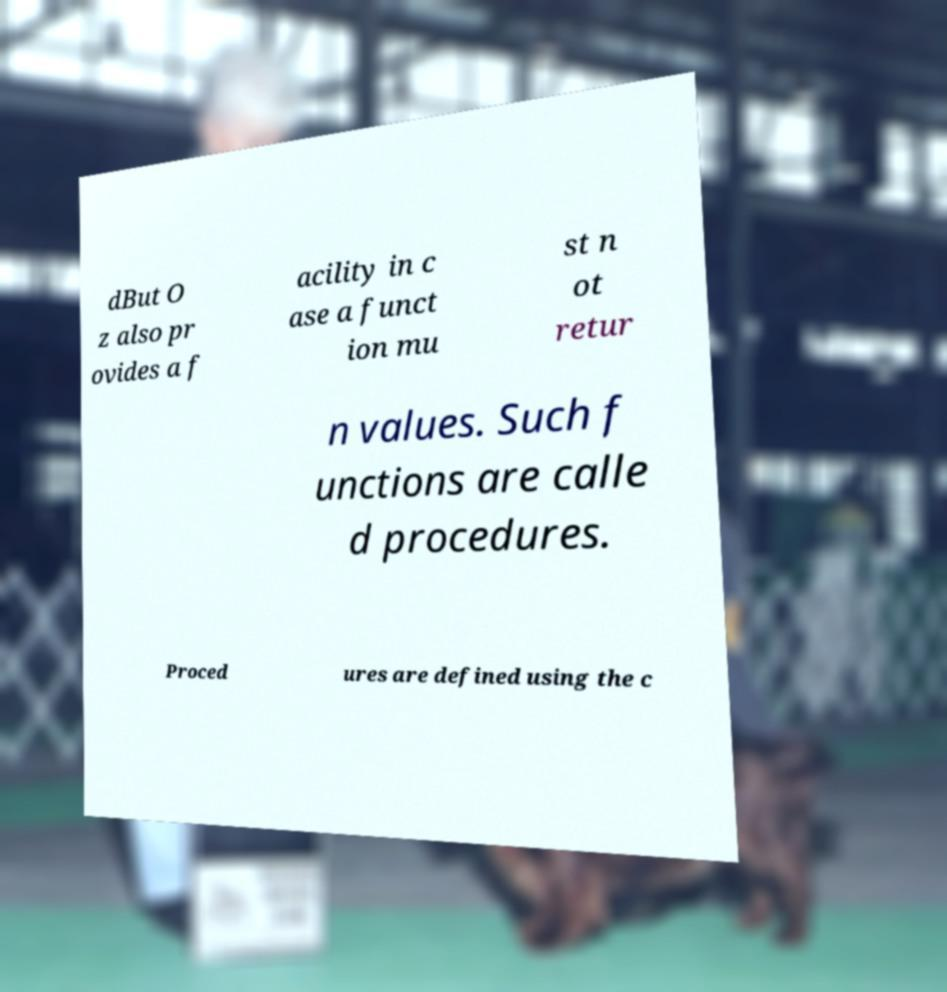For documentation purposes, I need the text within this image transcribed. Could you provide that? dBut O z also pr ovides a f acility in c ase a funct ion mu st n ot retur n values. Such f unctions are calle d procedures. Proced ures are defined using the c 